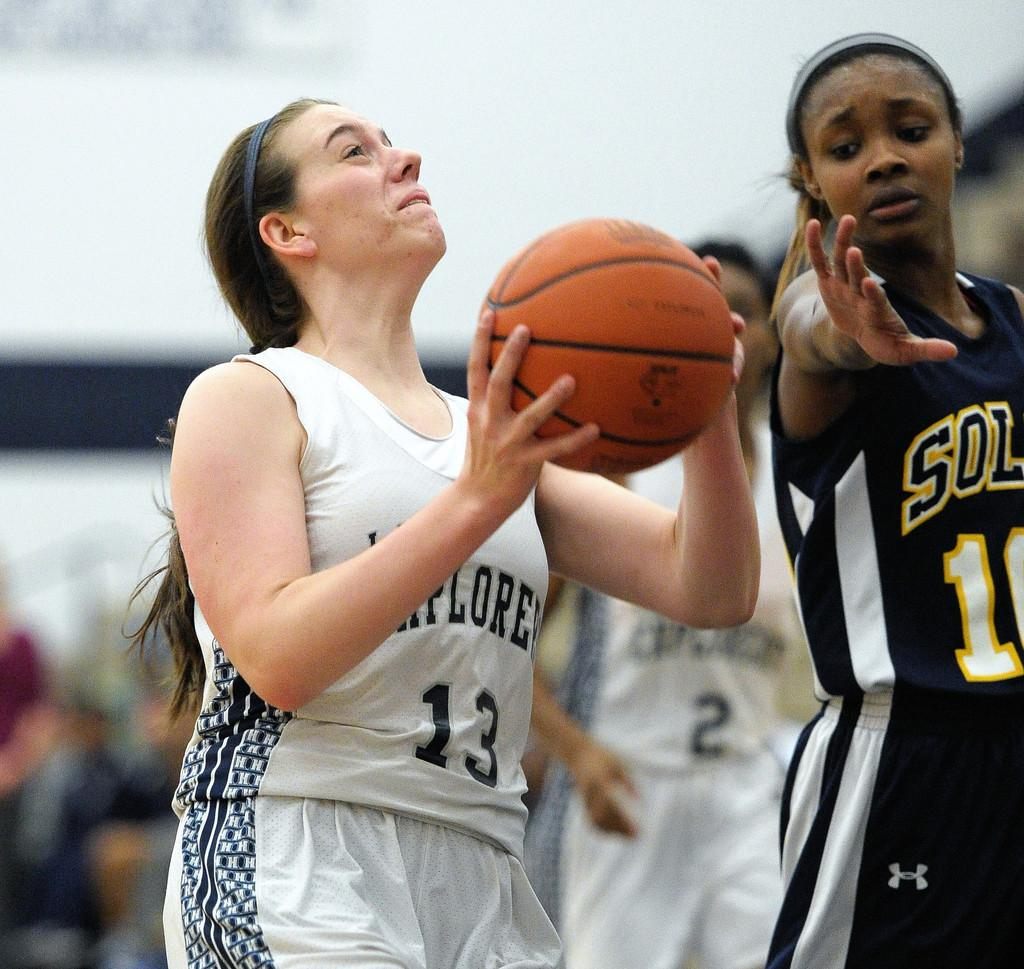Provide a one-sentence caption for the provided image. Women are playing the game of basketball on a court. 